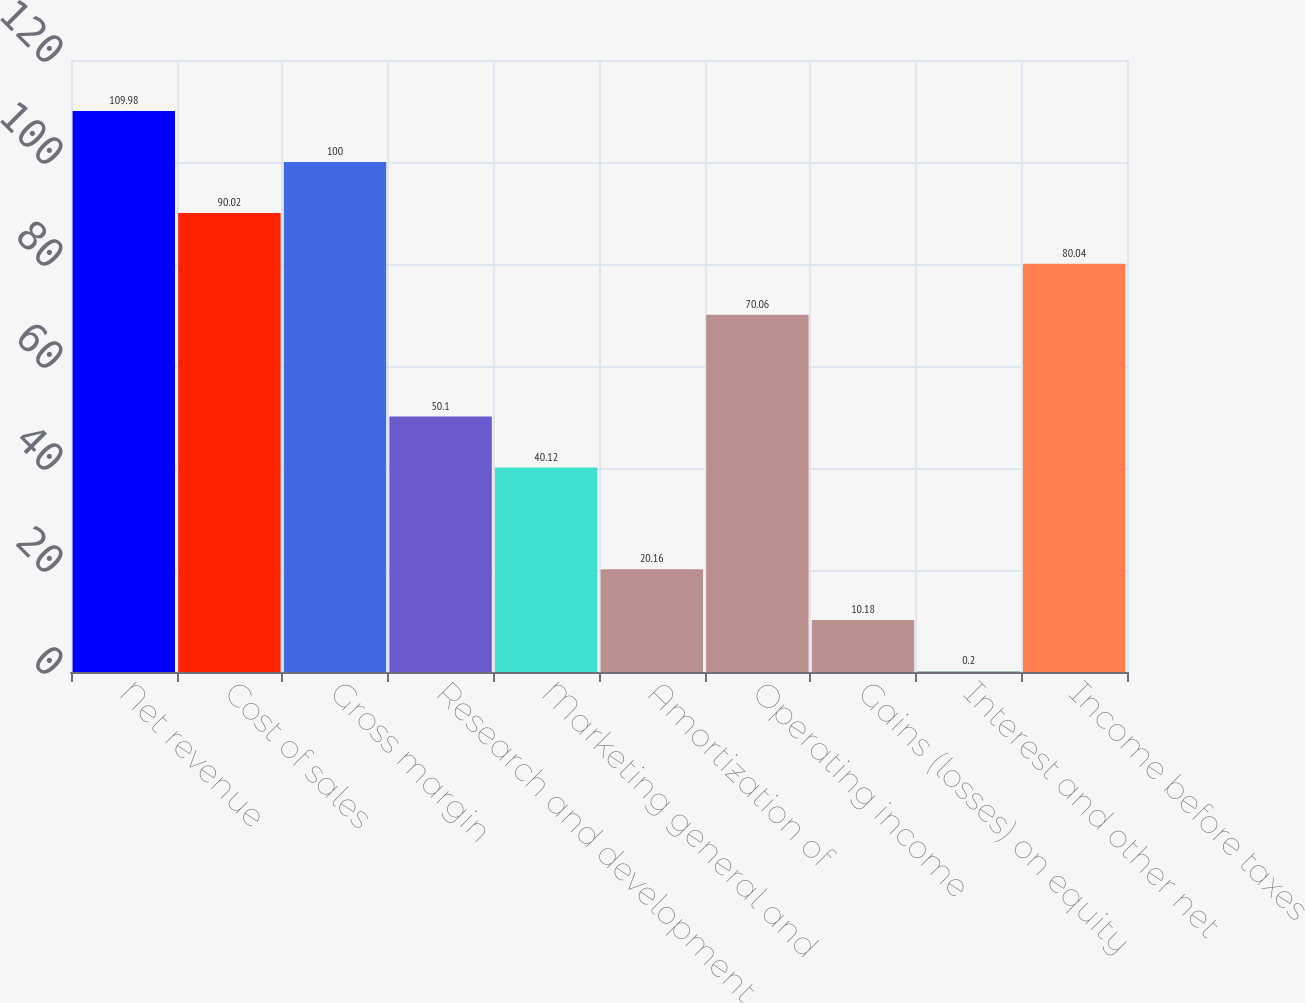Convert chart. <chart><loc_0><loc_0><loc_500><loc_500><bar_chart><fcel>Net revenue<fcel>Cost of sales<fcel>Gross margin<fcel>Research and development<fcel>Marketing general and<fcel>Amortization of<fcel>Operating income<fcel>Gains (losses) on equity<fcel>Interest and other net<fcel>Income before taxes<nl><fcel>109.98<fcel>90.02<fcel>100<fcel>50.1<fcel>40.12<fcel>20.16<fcel>70.06<fcel>10.18<fcel>0.2<fcel>80.04<nl></chart> 